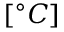<formula> <loc_0><loc_0><loc_500><loc_500>[ ^ { \circ } C ]</formula> 